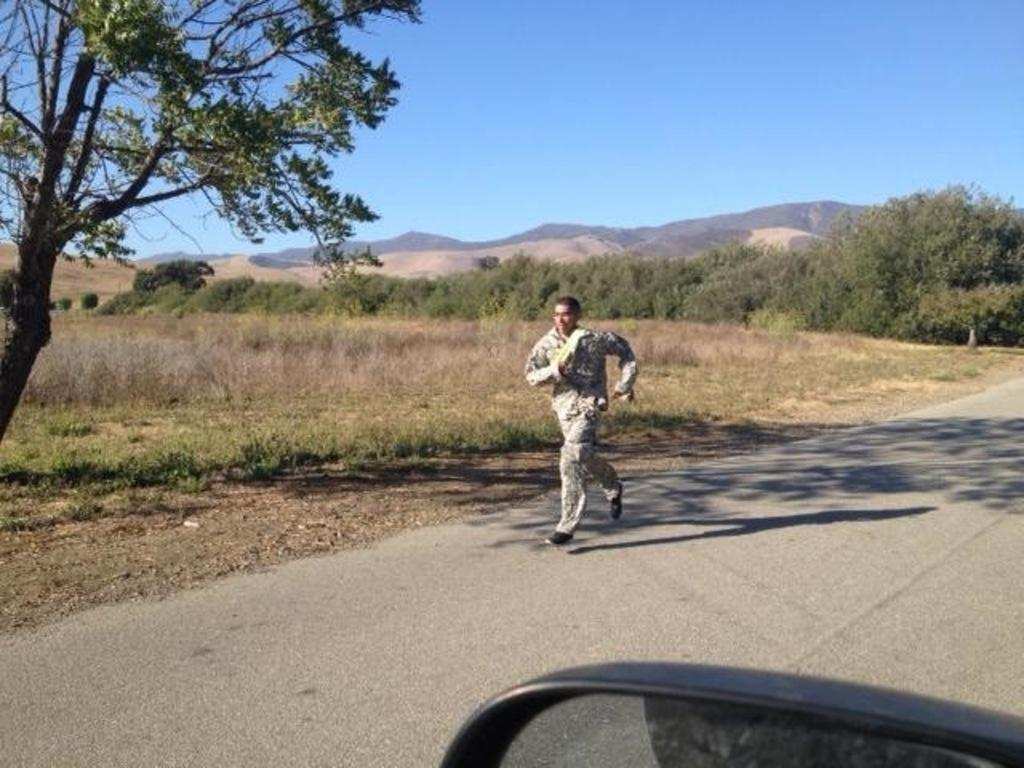What is the man in the image doing? The man is running on the road in the image. What type of vegetation can be seen in the image? There are dry plants and trees visible in the image. What is visible in the background of the image? There are mountains in the background of the image. What is present in the foreground of the image? There is a window of a vehicle in the foreground of the image. What type of apparel is the zebra wearing in the image? There is no zebra present in the image, so it is not possible to determine what apparel it might be wearing. 